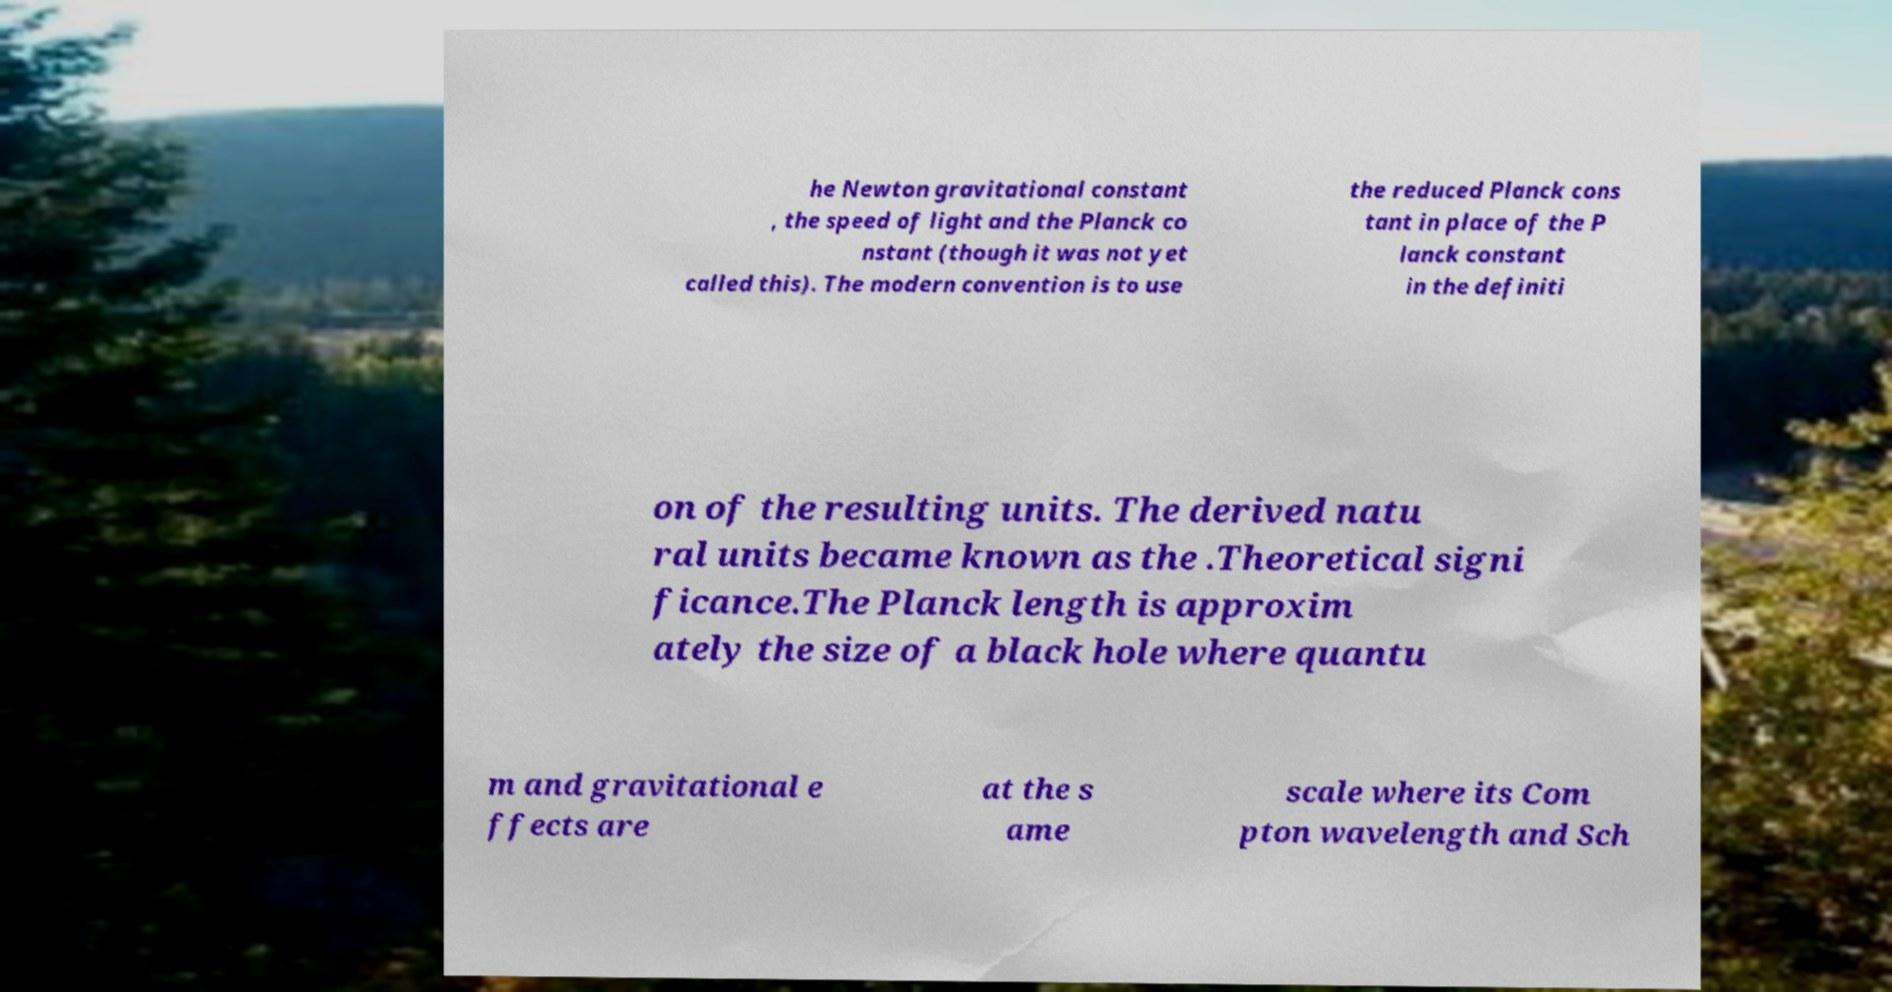Could you assist in decoding the text presented in this image and type it out clearly? he Newton gravitational constant , the speed of light and the Planck co nstant (though it was not yet called this). The modern convention is to use the reduced Planck cons tant in place of the P lanck constant in the definiti on of the resulting units. The derived natu ral units became known as the .Theoretical signi ficance.The Planck length is approxim ately the size of a black hole where quantu m and gravitational e ffects are at the s ame scale where its Com pton wavelength and Sch 